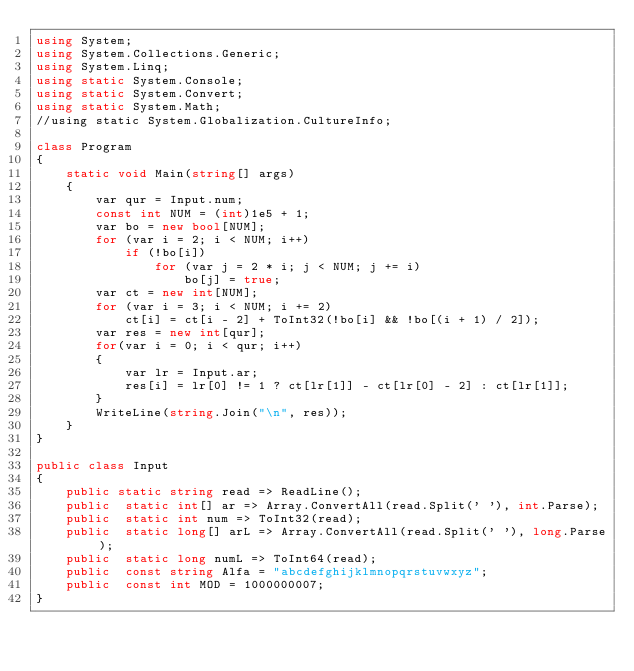<code> <loc_0><loc_0><loc_500><loc_500><_C#_>using System;
using System.Collections.Generic;
using System.Linq;
using static System.Console;
using static System.Convert;
using static System.Math;
//using static System.Globalization.CultureInfo;

class Program
{
    static void Main(string[] args)
    {
        var qur = Input.num;
        const int NUM = (int)1e5 + 1;
        var bo = new bool[NUM];
        for (var i = 2; i < NUM; i++)
            if (!bo[i])
                for (var j = 2 * i; j < NUM; j += i)
                    bo[j] = true;
        var ct = new int[NUM];
        for (var i = 3; i < NUM; i += 2)
            ct[i] = ct[i - 2] + ToInt32(!bo[i] && !bo[(i + 1) / 2]);
        var res = new int[qur];
        for(var i = 0; i < qur; i++)
        {
            var lr = Input.ar;
            res[i] = lr[0] != 1 ? ct[lr[1]] - ct[lr[0] - 2] : ct[lr[1]];
        }
        WriteLine(string.Join("\n", res));
    }
}

public class Input
{
    public static string read => ReadLine();
    public  static int[] ar => Array.ConvertAll(read.Split(' '), int.Parse);
    public  static int num => ToInt32(read);
    public  static long[] arL => Array.ConvertAll(read.Split(' '), long.Parse);
    public  static long numL => ToInt64(read);
    public  const string Alfa = "abcdefghijklmnopqrstuvwxyz";
    public  const int MOD = 1000000007;
}
</code> 